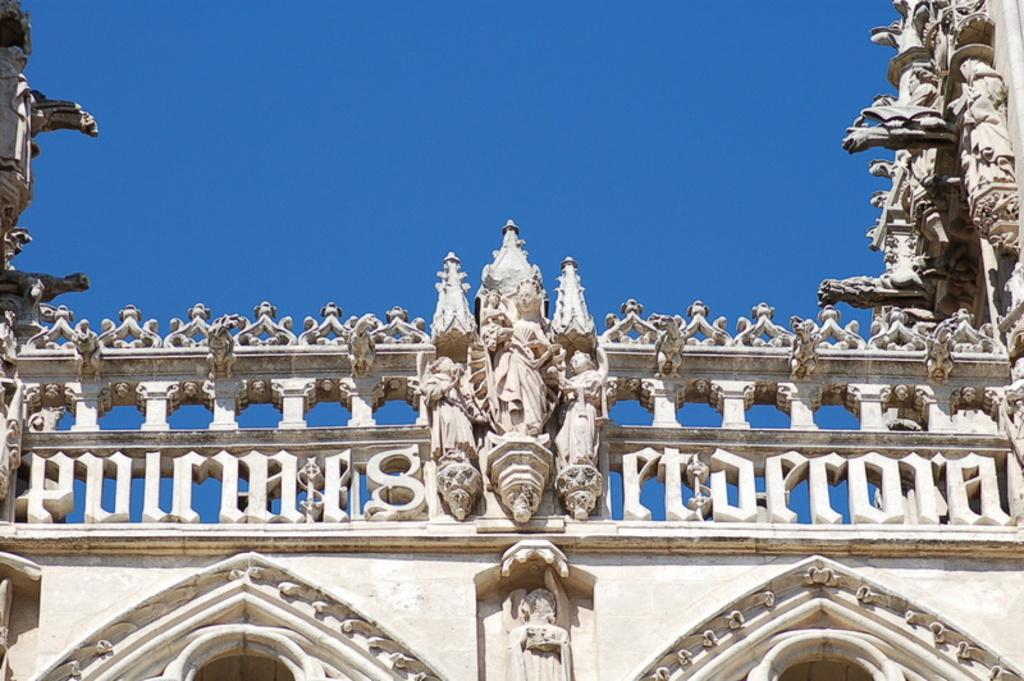What type of structure is present in the image? There is a building in the image. What decorative elements can be seen on the building? There are statues on the building. What color is the building in the image? The building is in cream color. What is the color of the sky in the image? The sky is blue in the image. What letter is being used to create the statues on the building? There is no indication in the image that the statues are made of letters or any other form of text. 